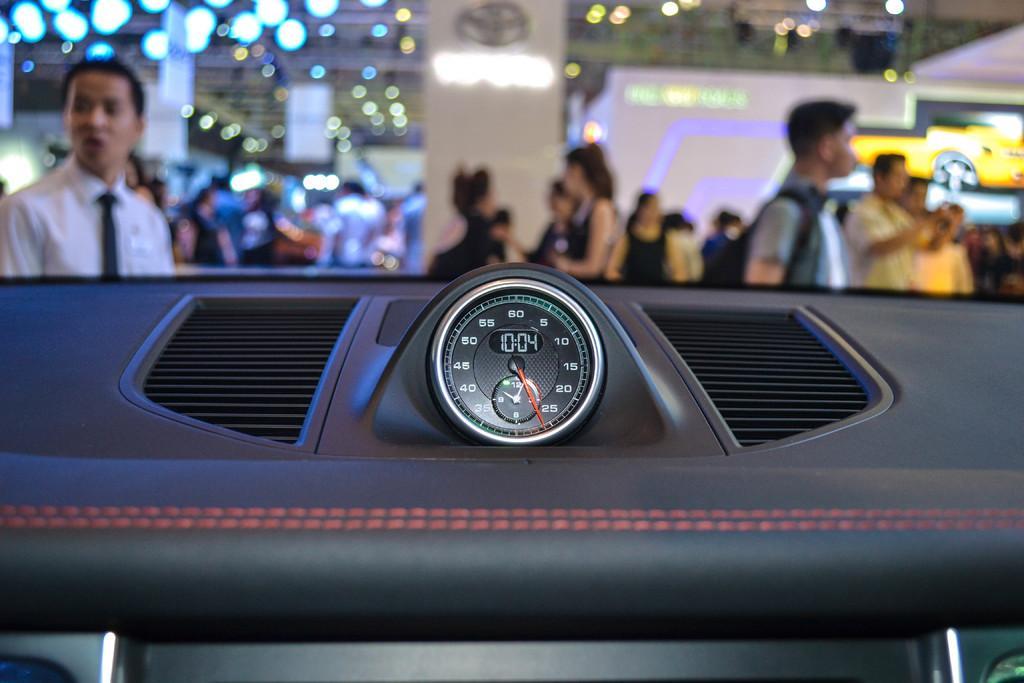Describe this image in one or two sentences. There is a speedometer. Here we can see group of people, boards, and lights. 